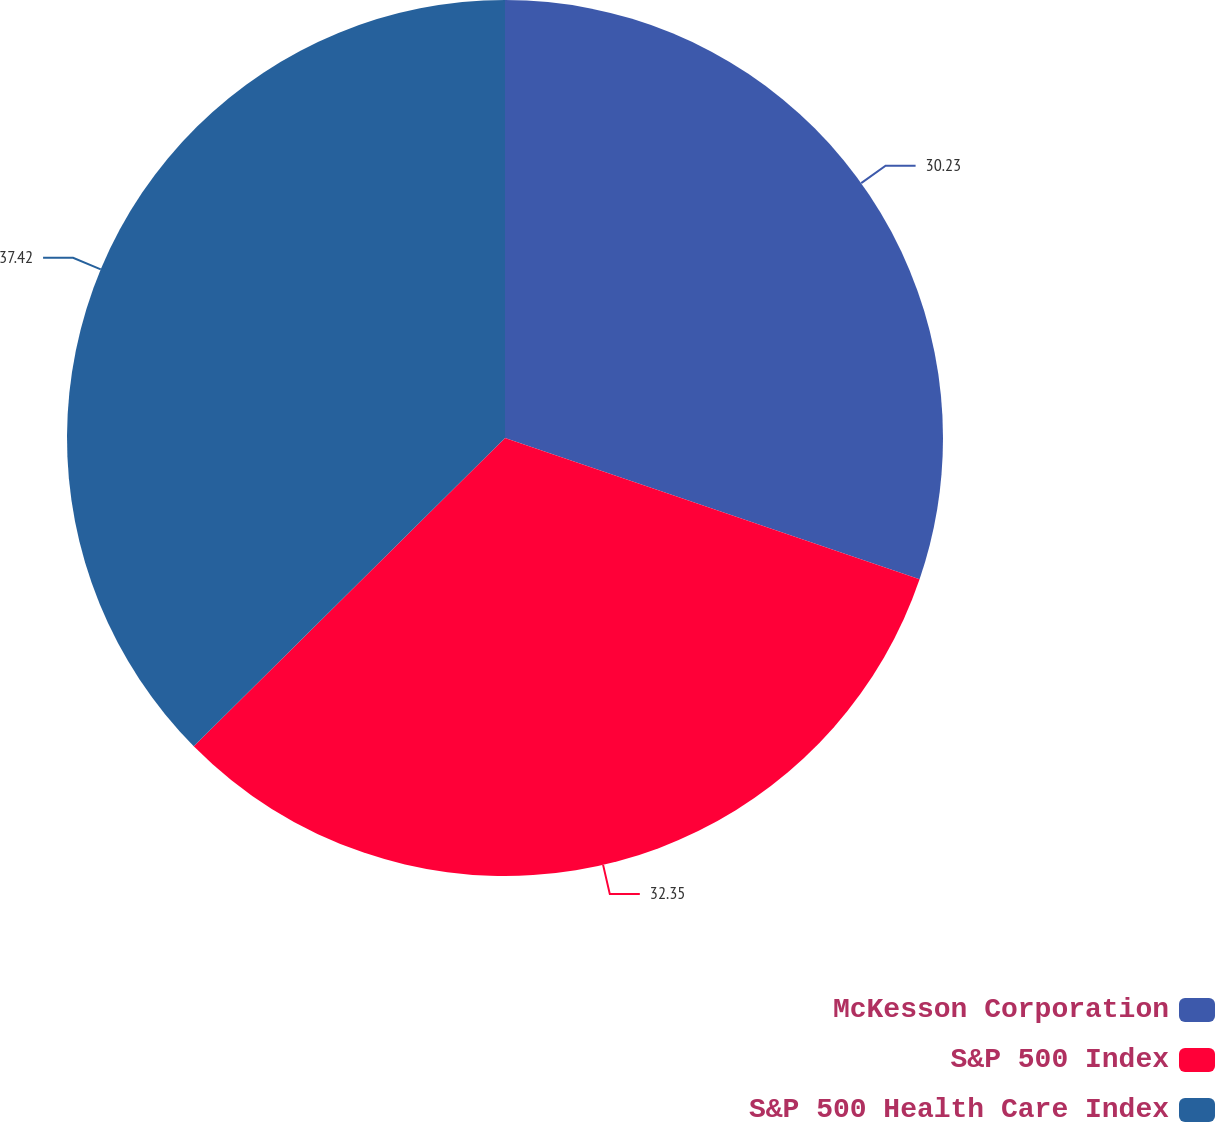Convert chart. <chart><loc_0><loc_0><loc_500><loc_500><pie_chart><fcel>McKesson Corporation<fcel>S&P 500 Index<fcel>S&P 500 Health Care Index<nl><fcel>30.23%<fcel>32.35%<fcel>37.42%<nl></chart> 